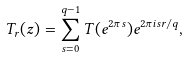Convert formula to latex. <formula><loc_0><loc_0><loc_500><loc_500>T _ { r } ( z ) = \sum _ { s = 0 } ^ { q - 1 } T ( e ^ { 2 \pi s } ) e ^ { 2 \pi i s r / q } ,</formula> 